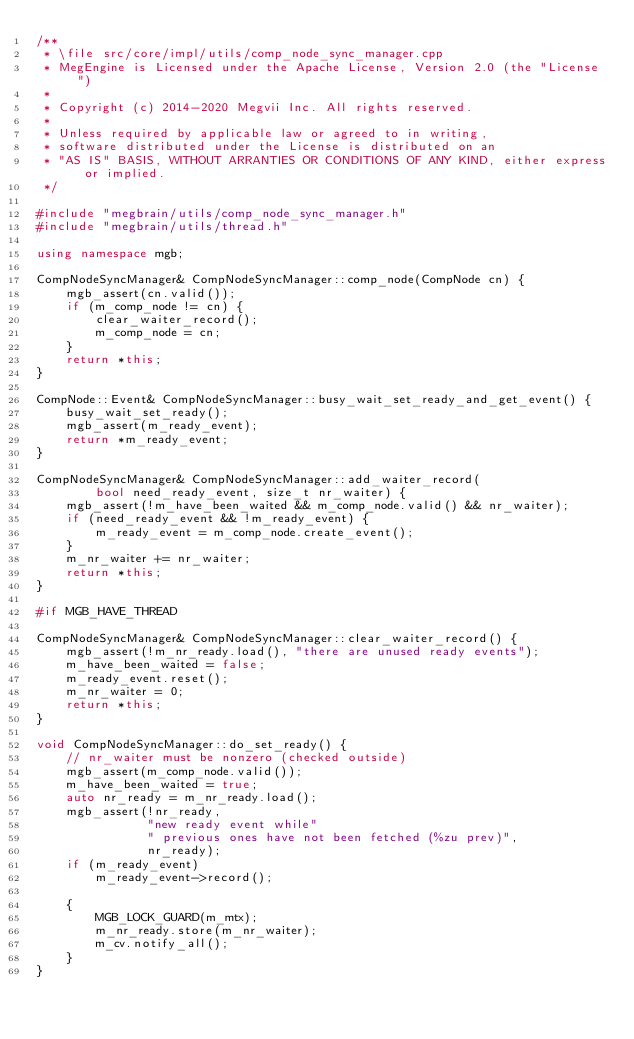Convert code to text. <code><loc_0><loc_0><loc_500><loc_500><_C++_>/**
 * \file src/core/impl/utils/comp_node_sync_manager.cpp
 * MegEngine is Licensed under the Apache License, Version 2.0 (the "License")
 *
 * Copyright (c) 2014-2020 Megvii Inc. All rights reserved.
 *
 * Unless required by applicable law or agreed to in writing,
 * software distributed under the License is distributed on an
 * "AS IS" BASIS, WITHOUT ARRANTIES OR CONDITIONS OF ANY KIND, either express or implied.
 */

#include "megbrain/utils/comp_node_sync_manager.h"
#include "megbrain/utils/thread.h"

using namespace mgb;

CompNodeSyncManager& CompNodeSyncManager::comp_node(CompNode cn) {
    mgb_assert(cn.valid());
    if (m_comp_node != cn) {
        clear_waiter_record();
        m_comp_node = cn;
    }
    return *this;
}

CompNode::Event& CompNodeSyncManager::busy_wait_set_ready_and_get_event() {
    busy_wait_set_ready();
    mgb_assert(m_ready_event);
    return *m_ready_event;
}

CompNodeSyncManager& CompNodeSyncManager::add_waiter_record(
        bool need_ready_event, size_t nr_waiter) {
    mgb_assert(!m_have_been_waited && m_comp_node.valid() && nr_waiter);
    if (need_ready_event && !m_ready_event) {
        m_ready_event = m_comp_node.create_event();
    }
    m_nr_waiter += nr_waiter;
    return *this;
}

#if MGB_HAVE_THREAD

CompNodeSyncManager& CompNodeSyncManager::clear_waiter_record() {
    mgb_assert(!m_nr_ready.load(), "there are unused ready events");
    m_have_been_waited = false;
    m_ready_event.reset();
    m_nr_waiter = 0;
    return *this;
}

void CompNodeSyncManager::do_set_ready() {
    // nr_waiter must be nonzero (checked outside)
    mgb_assert(m_comp_node.valid());
    m_have_been_waited = true;
    auto nr_ready = m_nr_ready.load();
    mgb_assert(!nr_ready,
               "new ready event while"
               " previous ones have not been fetched (%zu prev)",
               nr_ready);
    if (m_ready_event)
        m_ready_event->record();

    {
        MGB_LOCK_GUARD(m_mtx);
        m_nr_ready.store(m_nr_waiter);
        m_cv.notify_all();
    }
}
</code> 